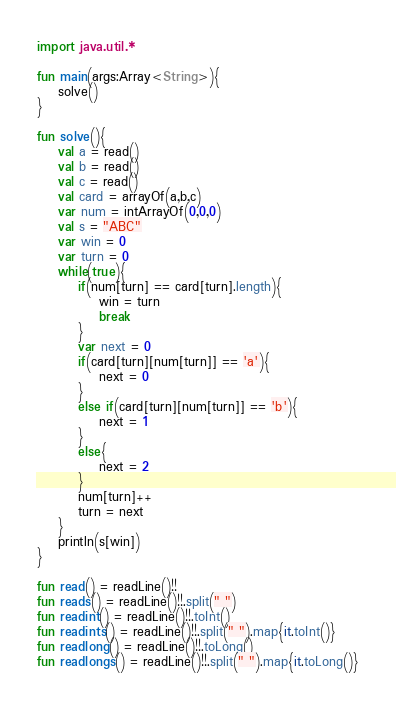Convert code to text. <code><loc_0><loc_0><loc_500><loc_500><_Kotlin_>import java.util.*

fun main(args:Array<String>){
    solve()
}

fun solve(){
    val a = read()
    val b = read()
    val c = read()
    val card = arrayOf(a,b,c)
    var num = intArrayOf(0,0,0)
    val s = "ABC"
    var win = 0
    var turn = 0
    while(true){
        if(num[turn] == card[turn].length){
            win = turn
            break
        }
        var next = 0
        if(card[turn][num[turn]] == 'a'){
            next = 0
        }
        else if(card[turn][num[turn]] == 'b'){
            next = 1
        }
        else{
            next = 2
        }
        num[turn]++
        turn = next
    }
    println(s[win])
}

fun read() = readLine()!!
fun reads() = readLine()!!.split(" ")
fun readint() = readLine()!!.toInt()
fun readints() = readLine()!!.split(" ").map{it.toInt()}
fun readlong() = readLine()!!.toLong()
fun readlongs() = readLine()!!.split(" ").map{it.toLong()}</code> 